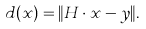<formula> <loc_0><loc_0><loc_500><loc_500>d ( x ) = \| H \cdot x - y \| .</formula> 